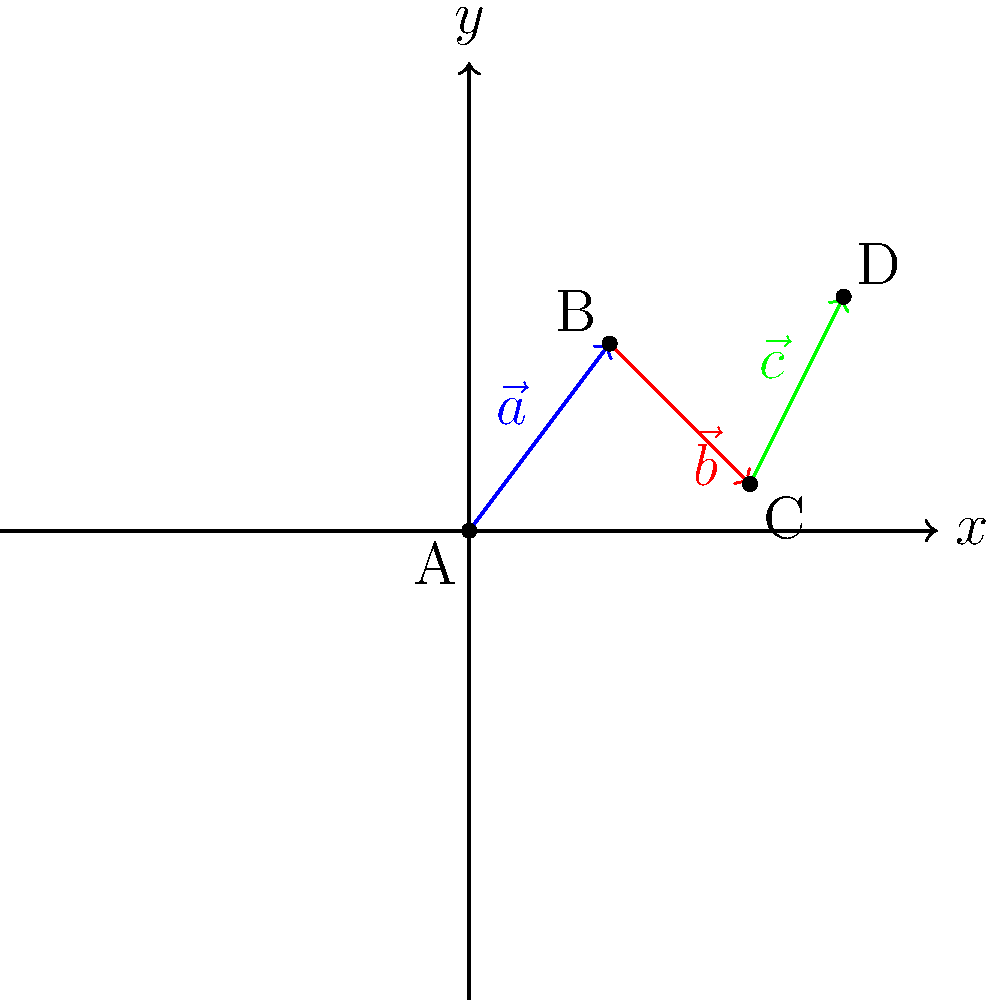In a self-defense scenario, you're mapping out a strategy using vectors on a coordinate grid. Vector $\vec{a}$ represents your initial defensive move, $\vec{b}$ is your evasive maneuver, and $\vec{c}$ is your final positioning. If $\vec{a} = \langle 3, 4 \rangle$, $\vec{b} = \langle 3, -3 \rangle$, and $\vec{c} = \langle 2, 4 \rangle$, what is the total displacement vector $\vec{d}$ from your starting position A to your final position D? Let's approach this step-by-step:

1) The total displacement vector $\vec{d}$ is the sum of all individual vectors: $\vec{d} = \vec{a} + \vec{b} + \vec{c}$

2) We're given:
   $\vec{a} = \langle 3, 4 \rangle$
   $\vec{b} = \langle 3, -3 \rangle$
   $\vec{c} = \langle 2, 4 \rangle$

3) To add vectors, we add their corresponding components:
   $\vec{d} = \langle 3, 4 \rangle + \langle 3, -3 \rangle + \langle 2, 4 \rangle$

4) Adding the x-components:
   $d_x = 3 + 3 + 2 = 8$

5) Adding the y-components:
   $d_y = 4 + (-3) + 4 = 5$

6) Therefore, the total displacement vector is:
   $\vec{d} = \langle 8, 5 \rangle$

This vector represents the direct path from your starting point A to your final position D, taking into account all the movements in between.
Answer: $\vec{d} = \langle 8, 5 \rangle$ 